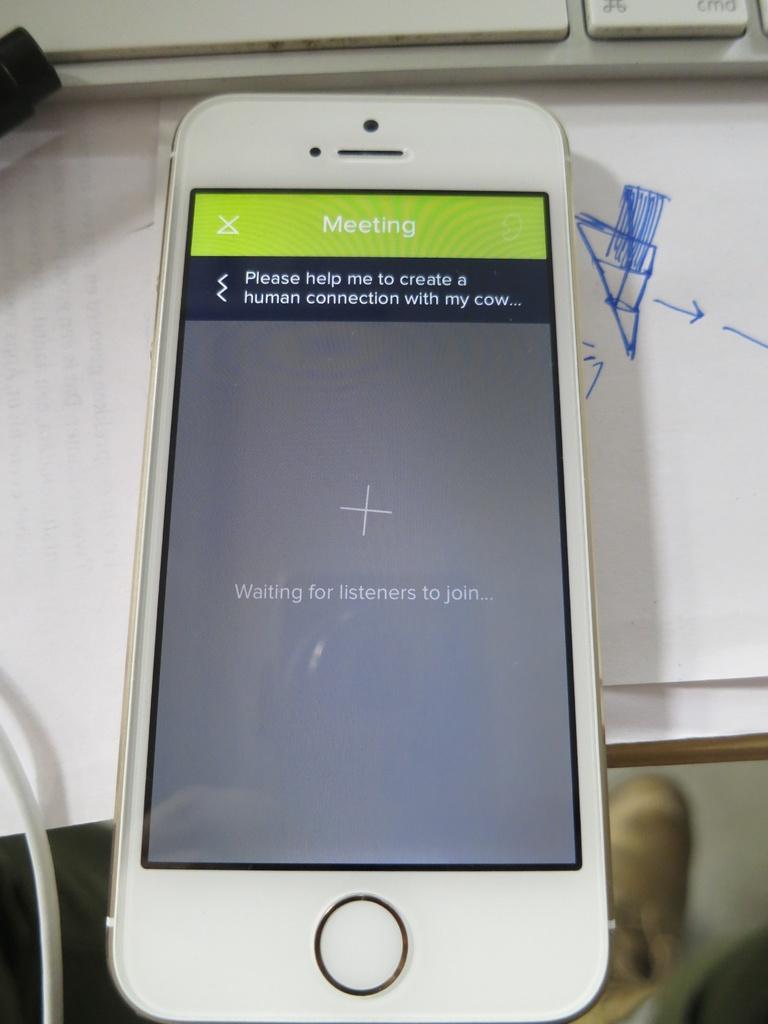What word is written on the top of the phone?
Keep it short and to the point. Meeting. What is the phone waiting for?
Your answer should be compact. Listeners to join. 